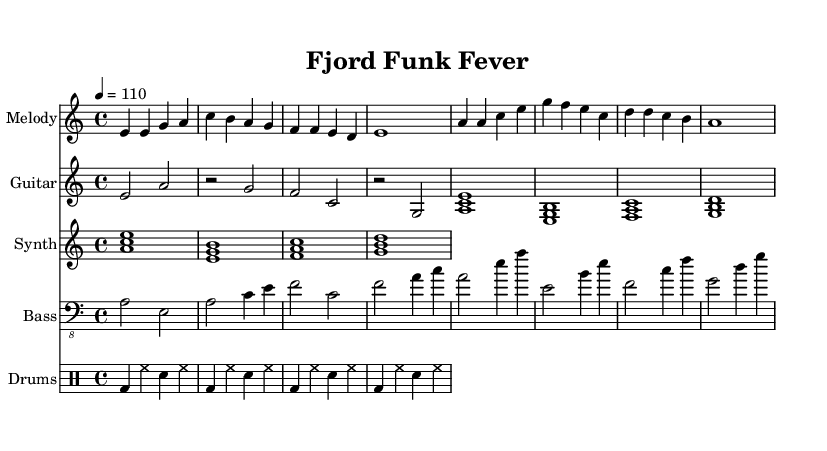What is the key signature of this music? The key signature appears at the beginning of the staff and indicates A minor, which has no sharps or flats. The presence of an A note as the tonic confirms this.
Answer: A minor What is the time signature of this music? The time signature is located at the beginning of the score, expressed as 4/4, indicating that there are four beats in each measure and a quarter note receives one beat.
Answer: 4/4 What is the tempo marking for this piece? The tempo is indicated at the beginning with "4 = 110," which signifies that the quarter note tempo is set to 110 beats per minute.
Answer: 110 How many measures are in the provided excerpt? By counting the distinct groups of beats, we can see that there are a total of 8 measures in the excerpt of the music.
Answer: 8 What chords are played during the chorus? The chords can be identified in the melody and electric guitar sections, which are A major, E minor, F major, and G major. These chords contribute to the harmonic structure in the chorus.
Answer: A, E minor, F, G Which instrument primarily features the melody? The melody is assigned to the staff labeled "Melody," which typically indicates the principal melodic line, often played by a lead instrument or sung.
Answer: Melody What type of rhythm pattern is used in the drums? The drum pattern includes a combination of bass drum (bd) and snare (sn) hits alongside hi-hat (hh), which showcases a funk style groove typical in this genre.
Answer: Funk rhythm 